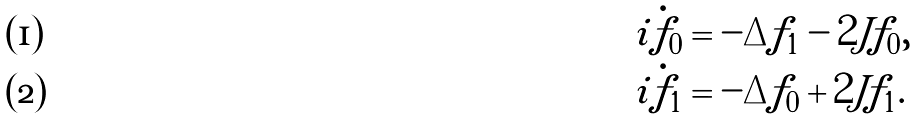Convert formula to latex. <formula><loc_0><loc_0><loc_500><loc_500>i \dot { f } _ { 0 } & = - \Delta f _ { 1 } - 2 J f _ { 0 } , \\ i \dot { f } _ { 1 } & = - \Delta f _ { 0 } + 2 J f _ { 1 } .</formula> 